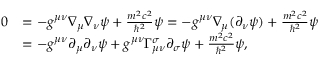<formula> <loc_0><loc_0><loc_500><loc_500>{ \begin{array} { r l } { 0 } & { = - g ^ { \mu \nu } \nabla _ { \mu } \nabla _ { \nu } \psi + { \frac { m ^ { 2 } c ^ { 2 } } { \hbar { ^ } { 2 } } } \psi = - g ^ { \mu \nu } \nabla _ { \mu } ( \partial _ { \nu } \psi ) + { \frac { m ^ { 2 } c ^ { 2 } } { \hbar { ^ } { 2 } } } \psi } \\ & { = - g ^ { \mu \nu } \partial _ { \mu } \partial _ { \nu } \psi + g ^ { \mu \nu } \Gamma ^ { \sigma } _ { \mu \nu } \partial _ { \sigma } \psi + { \frac { m ^ { 2 } c ^ { 2 } } { \hbar { ^ } { 2 } } } \psi , } \end{array} }</formula> 